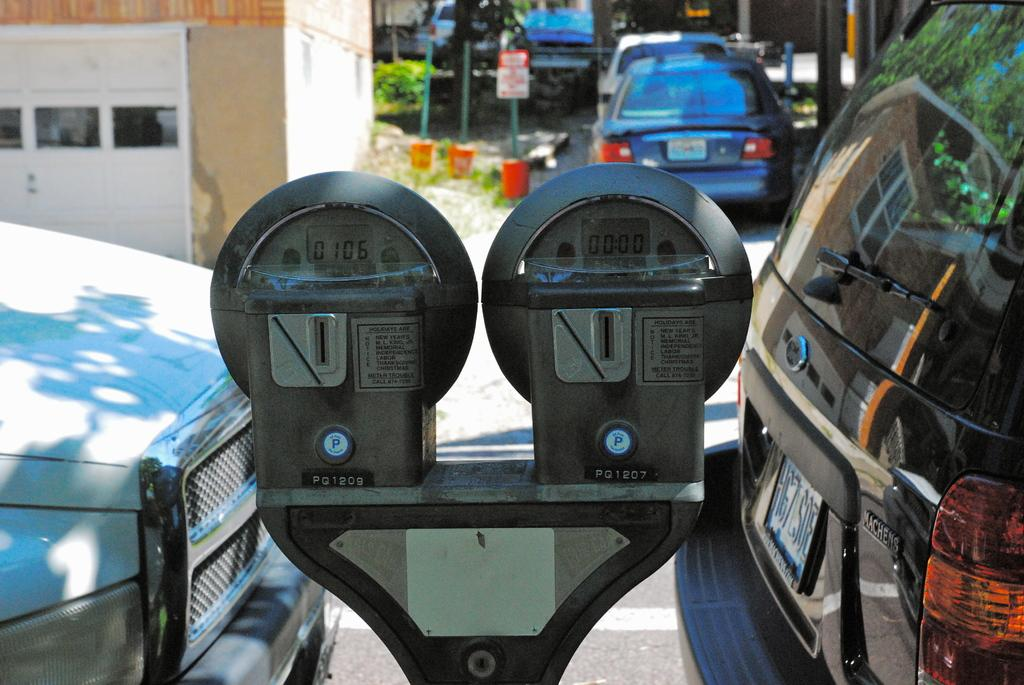<image>
Provide a brief description of the given image. Two parking meters with the left one showing numbers of 0106. 